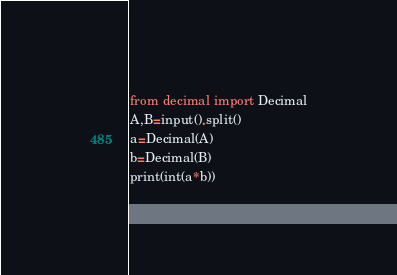Convert code to text. <code><loc_0><loc_0><loc_500><loc_500><_Python_>from decimal import Decimal
A,B=input().split()
a=Decimal(A)
b=Decimal(B)
print(int(a*b))
</code> 